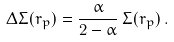<formula> <loc_0><loc_0><loc_500><loc_500>\Delta \Sigma ( r _ { p } ) = \frac { \alpha } { 2 - \alpha } \, \Sigma ( r _ { p } ) \, .</formula> 